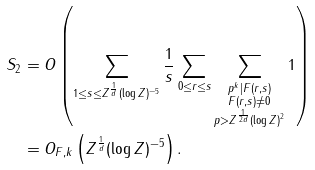<formula> <loc_0><loc_0><loc_500><loc_500>S _ { 2 } & = O \left ( \sum _ { 1 \leq s \leq Z ^ { \frac { 1 } { d } } ( \log Z ) ^ { - 5 } } \frac { 1 } { s } \sum _ { 0 \leq r \leq s } \sum _ { \substack { p ^ { k } | F ( r , s ) \\ F ( r , s ) \ne 0 \\ p > Z ^ { \frac { 1 } { 2 d } } ( \log Z ) ^ { 2 } } } 1 \right ) \\ & = O _ { F , k } \left ( Z ^ { \frac { 1 } { d } } ( \log Z ) ^ { - 5 } \right ) .</formula> 